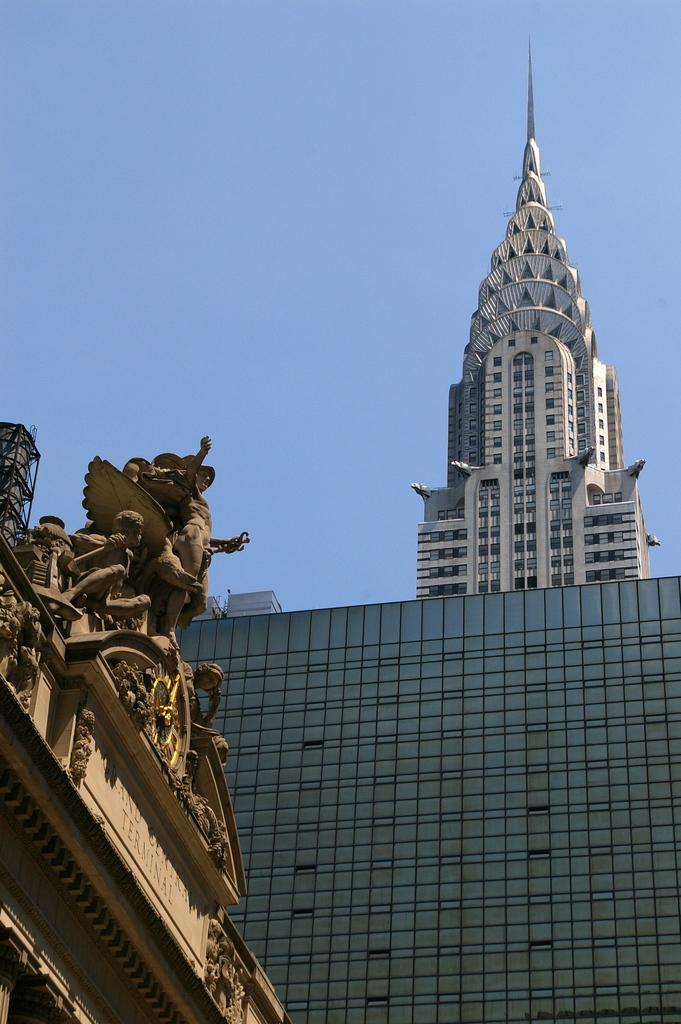What type of structure is located on the right side of the image? There is a building on the right side of the image. What specific feature can be seen on the building? The building has a tower-like structure. Are there any decorative elements on the building? Yes, there are sculptures on the building. What is the condition of the sky in the image? The sky is clear in the image. How many wheels can be seen on the building in the image? There are no wheels present on the building in the image. Is there a beggar visible in the image? There is no beggar present in the image. 